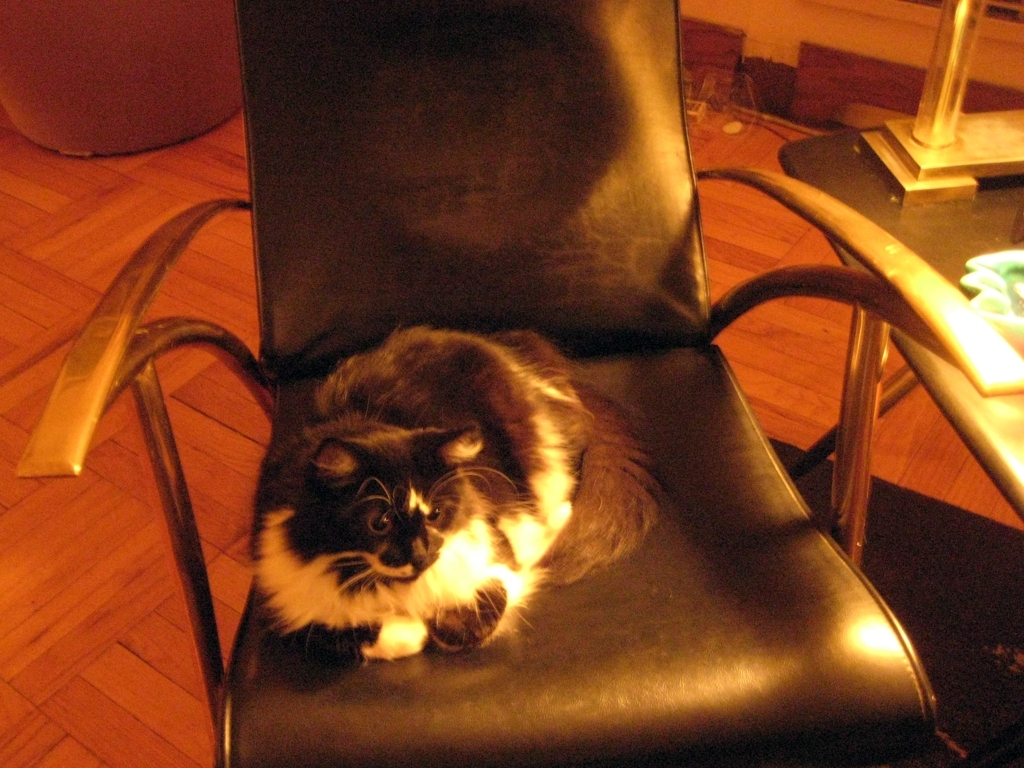What are the primary features of the cat and chair in the picture? The cat in the image has a black and white fur coat with prominent fluffy tufts around its neck and ears suggestive of a longer fur breed, and a pair of alert, bright eyes. The chair is a modern design with a sleek black leather upholstery and curved metal armrests that give it a contemporary feel. 